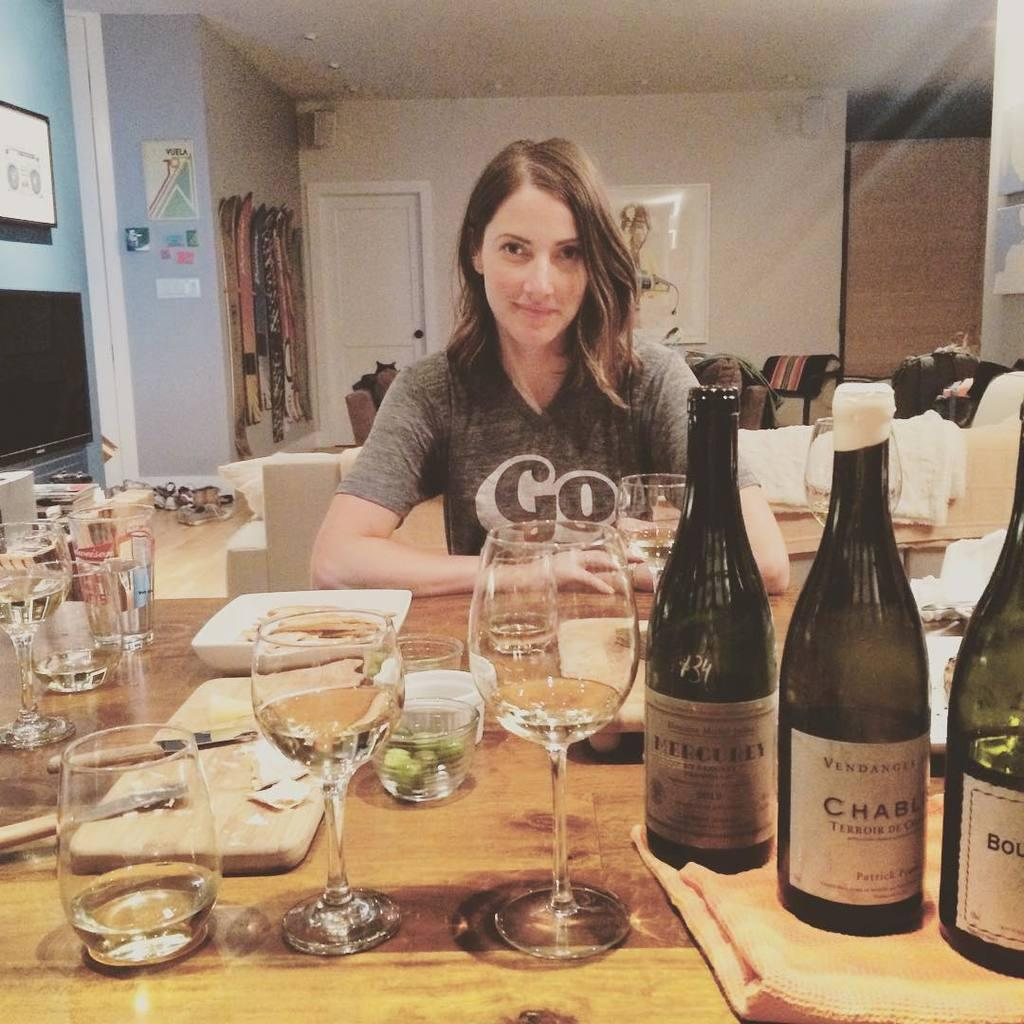<image>
Write a terse but informative summary of the picture. A woman wearing a t-shirt that says Go sits at a table. 